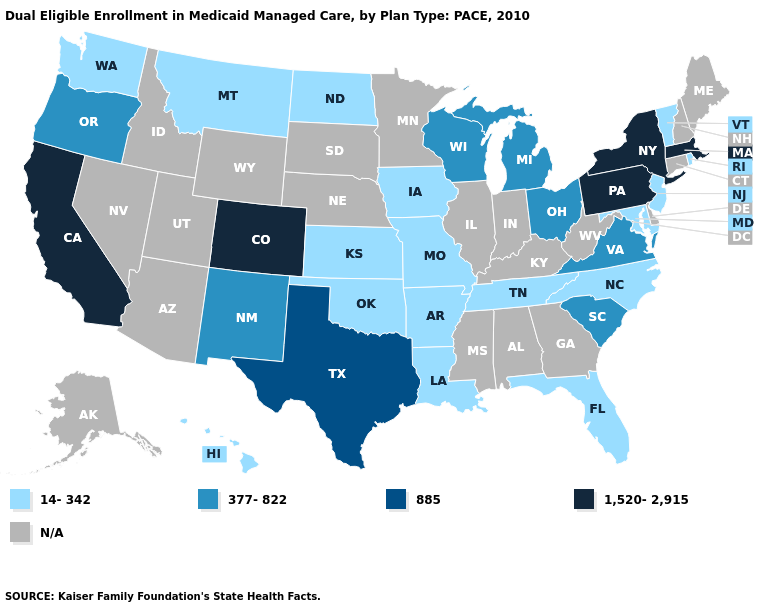What is the highest value in states that border New Mexico?
Answer briefly. 1,520-2,915. Which states have the lowest value in the South?
Answer briefly. Arkansas, Florida, Louisiana, Maryland, North Carolina, Oklahoma, Tennessee. Name the states that have a value in the range N/A?
Keep it brief. Alabama, Alaska, Arizona, Connecticut, Delaware, Georgia, Idaho, Illinois, Indiana, Kentucky, Maine, Minnesota, Mississippi, Nebraska, Nevada, New Hampshire, South Dakota, Utah, West Virginia, Wyoming. Does California have the highest value in the West?
Give a very brief answer. Yes. Name the states that have a value in the range N/A?
Write a very short answer. Alabama, Alaska, Arizona, Connecticut, Delaware, Georgia, Idaho, Illinois, Indiana, Kentucky, Maine, Minnesota, Mississippi, Nebraska, Nevada, New Hampshire, South Dakota, Utah, West Virginia, Wyoming. Which states have the highest value in the USA?
Give a very brief answer. California, Colorado, Massachusetts, New York, Pennsylvania. Name the states that have a value in the range 1,520-2,915?
Answer briefly. California, Colorado, Massachusetts, New York, Pennsylvania. Among the states that border Delaware , which have the highest value?
Keep it brief. Pennsylvania. Does Rhode Island have the lowest value in the USA?
Concise answer only. Yes. What is the value of North Carolina?
Write a very short answer. 14-342. Name the states that have a value in the range 1,520-2,915?
Quick response, please. California, Colorado, Massachusetts, New York, Pennsylvania. What is the value of Delaware?
Quick response, please. N/A. What is the highest value in states that border West Virginia?
Keep it brief. 1,520-2,915. What is the lowest value in the West?
Answer briefly. 14-342. Among the states that border Nevada , does Oregon have the lowest value?
Be succinct. Yes. 